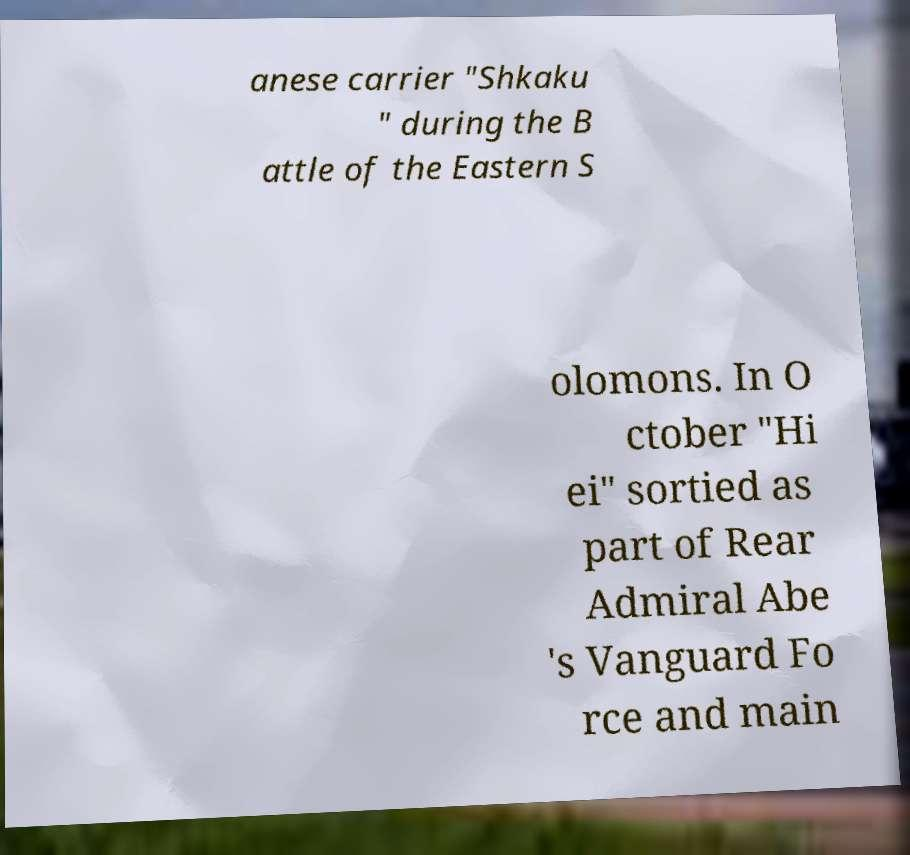Could you assist in decoding the text presented in this image and type it out clearly? anese carrier "Shkaku " during the B attle of the Eastern S olomons. In O ctober "Hi ei" sortied as part of Rear Admiral Abe 's Vanguard Fo rce and main 